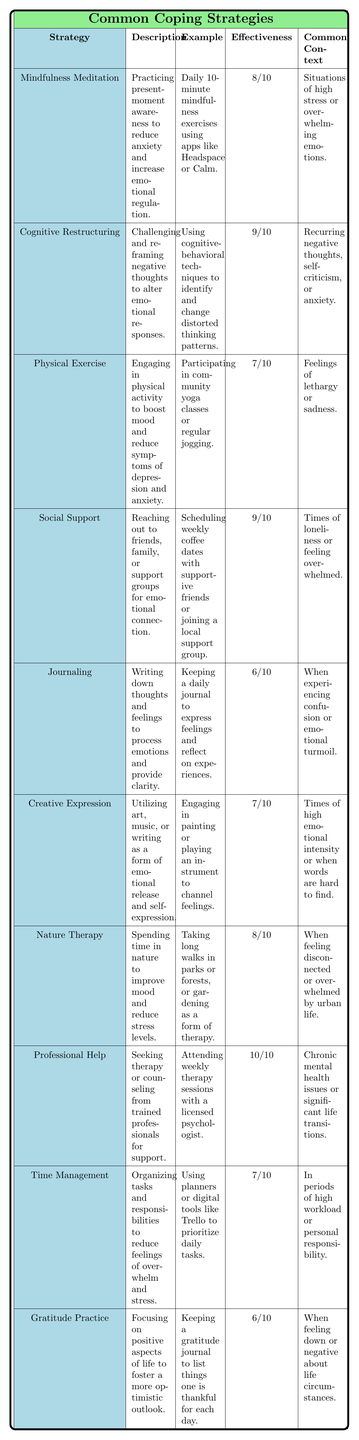What is the effectiveness rating of Professional Help? The table shows that the effectiveness rating for Professional Help is 10/10, which is the highest rating among the strategies listed.
Answer: 10/10 How many coping strategies have an effectiveness rating of 8 or higher? The strategies with an effectiveness rating of 8 or higher are Mindfulness Meditation, Cognitive Restructuring, Social Support, Nature Therapy, and Professional Help, totaling 5 strategies.
Answer: 5 Is Journaling considered a high effectiveness coping strategy? Journaling has an effectiveness rating of 6/10, which is below the midpoint of 7, indicating it is not considered high effectiveness.
Answer: No Which coping strategy focuses on physical activity? Physical Exercise is the strategy that emphasizes engaging in physical activity to boost mood and reduce symptoms of depression and anxiety.
Answer: Physical Exercise What is the common context for Cognitive Restructuring? The common context for Cognitive Restructuring is when individuals experience recurring negative thoughts, self-criticism, or anxiety, indicating its use in specific scenarios.
Answer: Recurring negative thoughts, self-criticism, or anxiety What is the average effectiveness rating of the listed coping strategies? To calculate the average, sum the effectiveness ratings: (8 + 9 + 7 + 9 + 6 + 7 + 8 + 10 + 7 + 6) = 78. There are 10 strategies, so the average is 78/10 = 7.8.
Answer: 7.8 Which strategy has an example of keeping a gratitude journal? The Gratitude Practice strategy has an example of keeping a gratitude journal to list things one is thankful for each day.
Answer: Gratitude Practice Are there more strategies with an effectiveness rating of 6 than those rated higher? There are two strategies (Journaling and Gratitude Practice) rated at 6, while there are five strategies rated higher than 6. Therefore, more strategies are rated higher than 6.
Answer: No What coping strategy is listed for feelings of lethargy or sadness? Physical Exercise is the strategy associated with feelings of lethargy or sadness, as it encourages engaging in physical activities to improve mood.
Answer: Physical Exercise What common context is linked to Nature Therapy? Nature Therapy is commonly linked to feelings of disconnect or being overwhelmed by urban life, as it involves spending time in nature to improve mood.
Answer: Feeling disconnected or overwhelmed by urban life Which two strategies have the same effectiveness rating of 7? The strategies Physical Exercise and Creative Expression both have an effectiveness rating of 7/10, highlighting their moderate effectiveness.
Answer: Physical Exercise and Creative Expression 